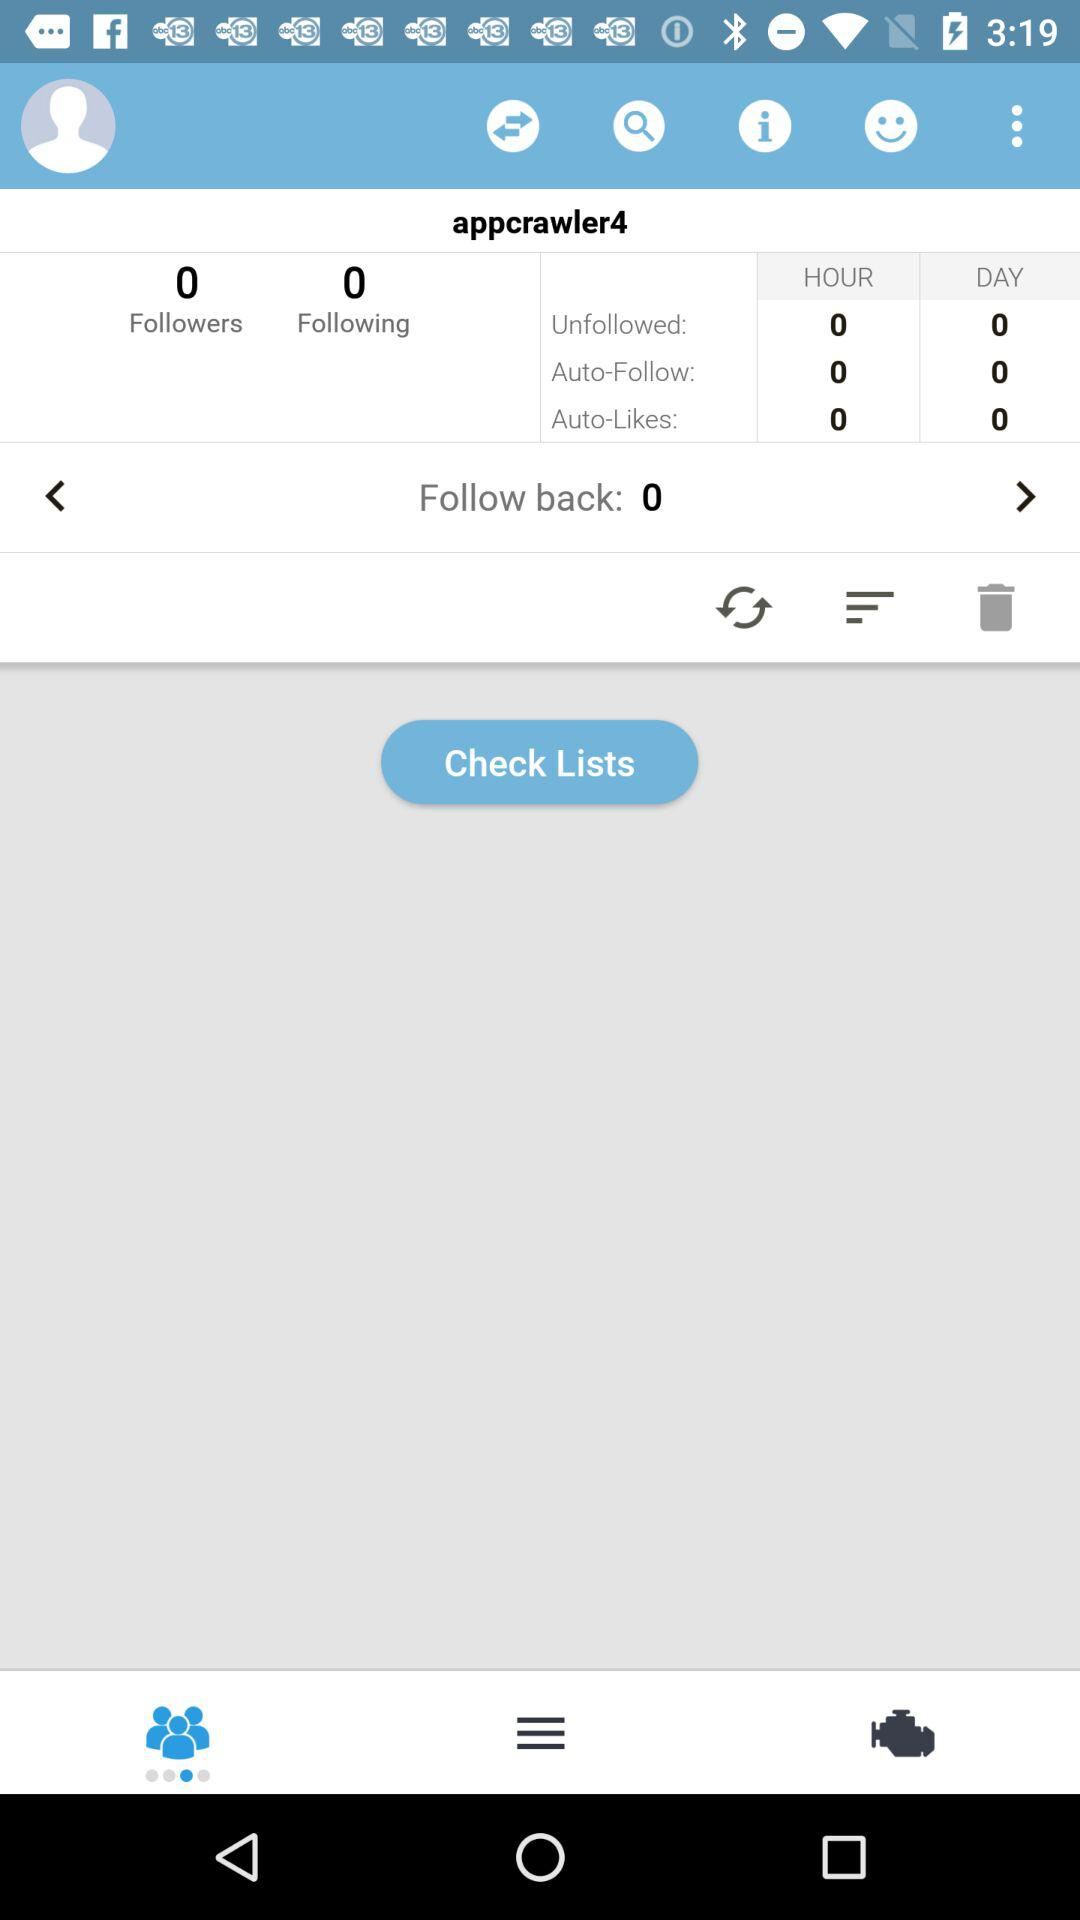How many followers are there? There are 0 followers. 